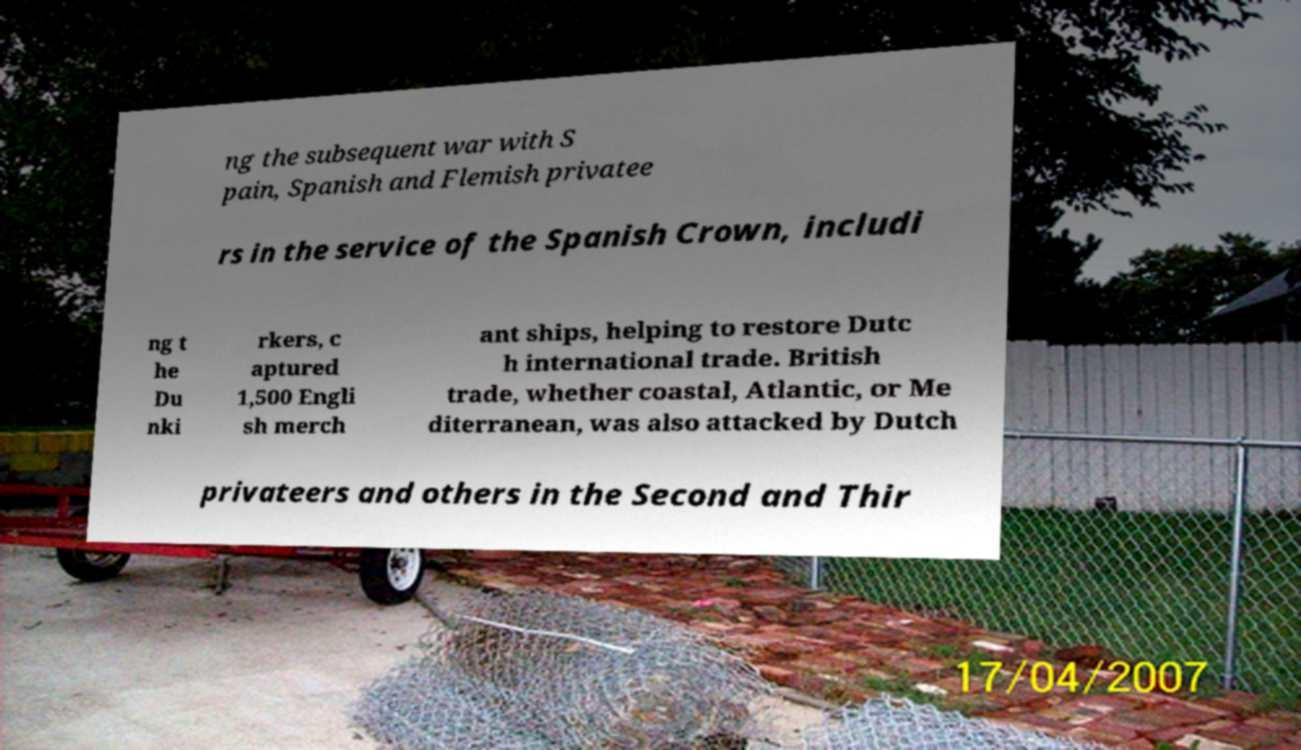I need the written content from this picture converted into text. Can you do that? ng the subsequent war with S pain, Spanish and Flemish privatee rs in the service of the Spanish Crown, includi ng t he Du nki rkers, c aptured 1,500 Engli sh merch ant ships, helping to restore Dutc h international trade. British trade, whether coastal, Atlantic, or Me diterranean, was also attacked by Dutch privateers and others in the Second and Thir 